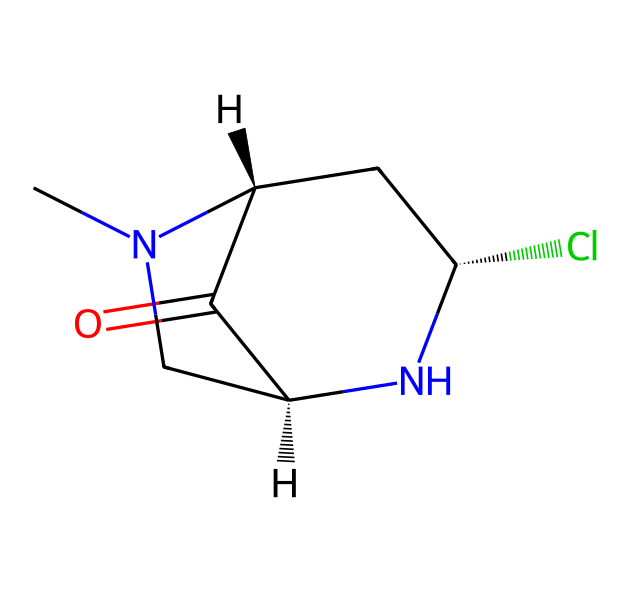What is the main functional group in this molecule? The molecule contains a carbonyl group (C=O) as part of a cyclic structure, which classifies it as containing an amide function since it also has nitrogen atoms adjacent to the carbonyl group.
Answer: carbonyl How many nitrogen atoms are present in the structure? By examining the SMILES representation, we can identify two nitrogen atoms. They can be visually confirmed when we note that one nitrogen is part of an amine group, and the other is part of a cyclic structure.
Answer: two What type of compound is represented by the given structure? The structure indicates that this compound is a neonicotinoid, which can be inferred from the characteristics of containing both nitrogen and chlorine atoms, typical of this class of pesticides.
Answer: neonicotinoid What is the stereochemistry of the two chiral centers in this molecule? The molecule has specific stereochemical configurations indicated by the “@” symbols in the SMILES, which denote chiral centers at those positions. The first center is marked as S and the second as R, confirming their configurations.
Answer: S, R What role do the chlorine atoms play in the chemical's activity? Chlorine atoms in neonicotinoids are known to enhance lipophilicity and improve binding affinity to insect neurotransmitter receptors, which increases their effectiveness as pesticides.
Answer: enhance activity What is the total number of carbon atoms in this structure? Counting the carbon atoms present in the molecular structure, we find there are six carbon atoms. This is apparent through analyzing the connections and parts of the cyclic portion of the molecule.
Answer: six 